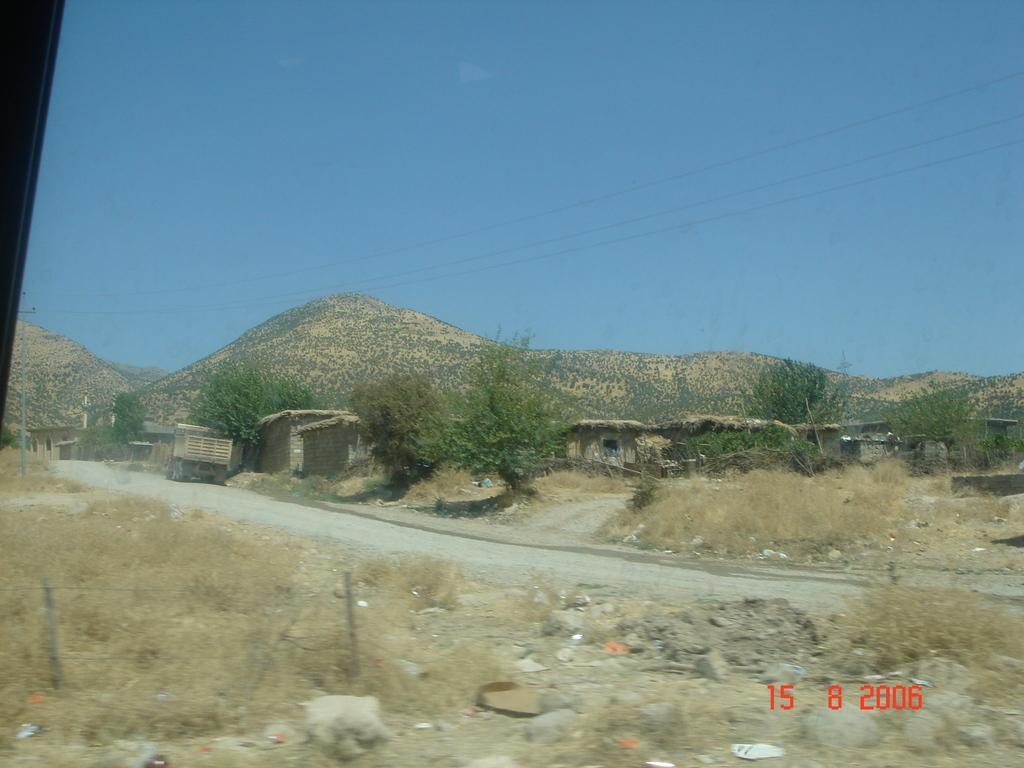What type of vegetation is present in the image? There is grass in the image. What other objects can be seen on the ground? There are stones in the image. What type of structures are visible in the image? There are houses in the image. What natural features are present in the image? There are trees and mountains in the image. What man-made structures are present in the image? There is a light pole in the image. What else can be seen in the image that is related to human infrastructure? There are wires in the image. What part of the natural environment is visible in the image? The sky is visible in the image. Based on the visible sky and lighting, when do you think the image was taken? The image was likely taken during the day. What type of hat is the tree wearing in the image? There are no hats present in the image, and trees do not wear hats. How is the glue holding the mountains together in the image? There is no glue present in the image, and mountains do not require glue to hold them together. 